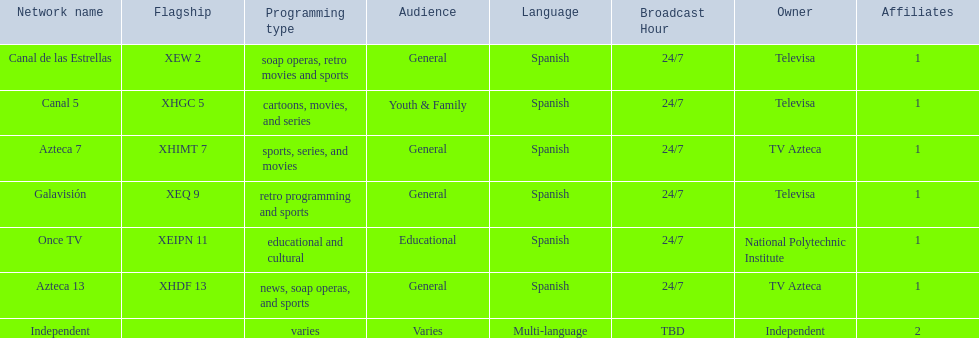What is the average number of affiliates that a given network will have? 1. 